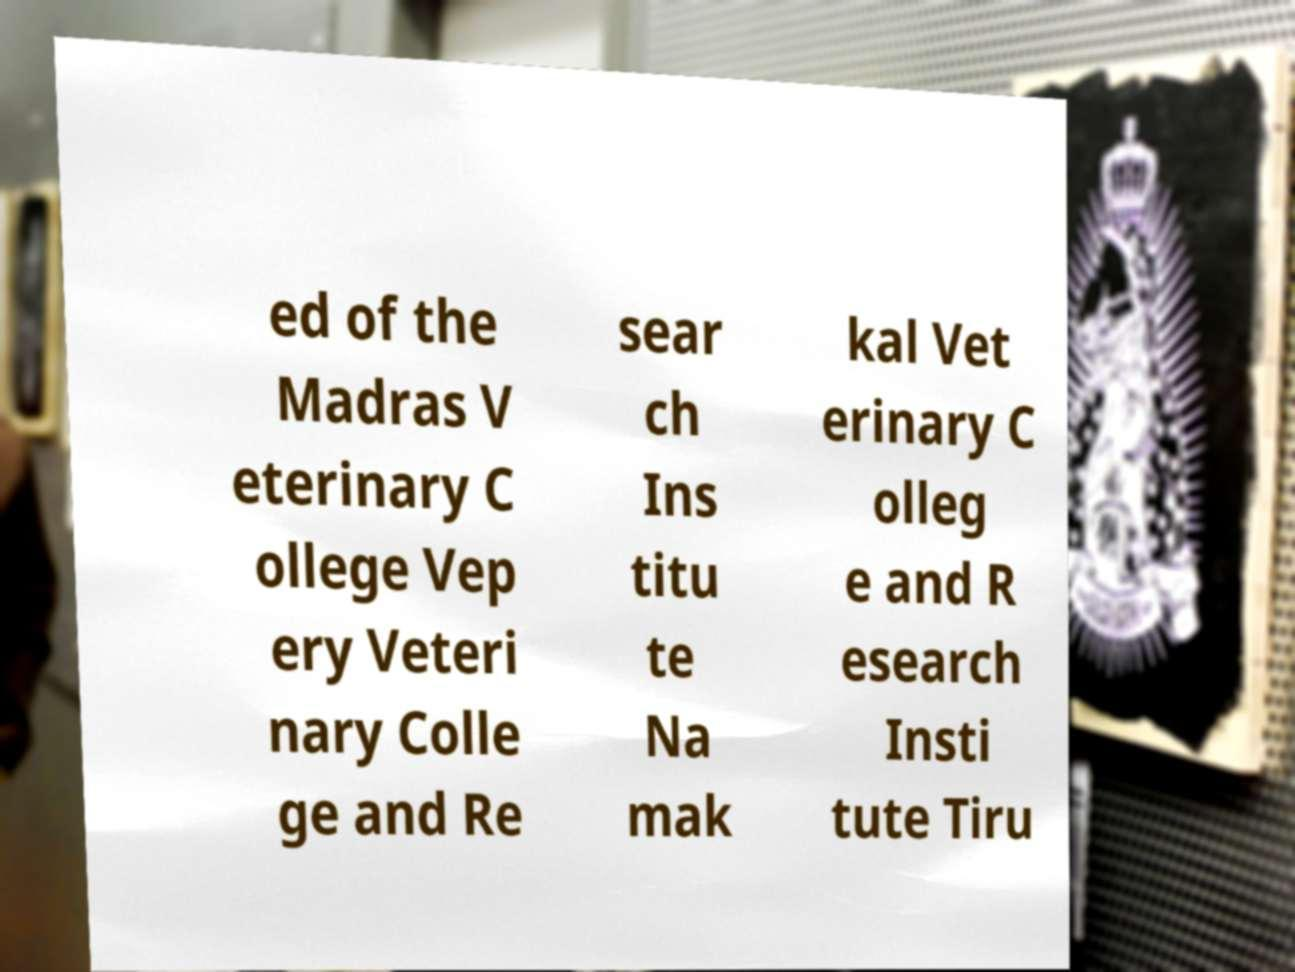There's text embedded in this image that I need extracted. Can you transcribe it verbatim? ed of the Madras V eterinary C ollege Vep ery Veteri nary Colle ge and Re sear ch Ins titu te Na mak kal Vet erinary C olleg e and R esearch Insti tute Tiru 